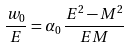Convert formula to latex. <formula><loc_0><loc_0><loc_500><loc_500>\frac { w _ { 0 } } { E } = \alpha _ { 0 } \, \frac { E ^ { 2 } - M ^ { 2 } } { E M }</formula> 